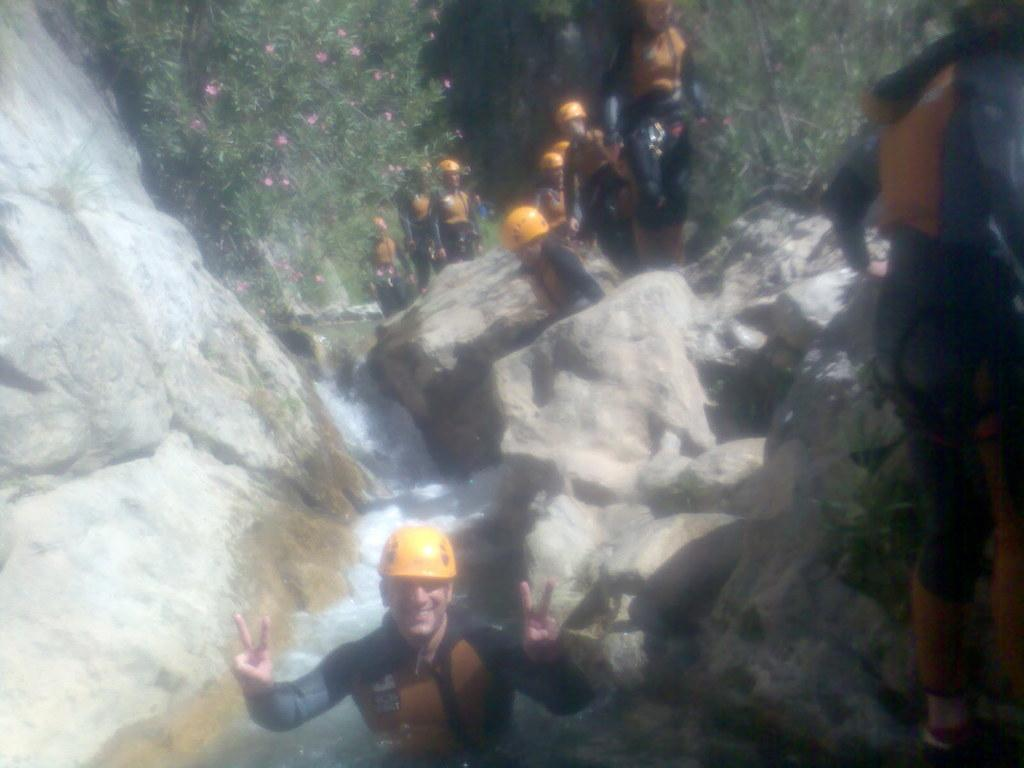What natural feature is the main subject of the image? There is a waterfall in the image. What else can be seen in the image besides the waterfall? There are rocks, people, a hill, and trees in the image. Where is the hill located in the image? The hill is on the left side of the image. What type of vegetation is present in the image? There are trees in the image. What type of veil is being worn by the waterfall in the image? There is no veil present in the image, as the main subject is a waterfall, which is a natural feature and not a person wearing a veil. 